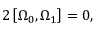<formula> <loc_0><loc_0><loc_500><loc_500>2 \left [ \Omega _ { 0 } , \Omega _ { 1 } \right ] = 0 ,</formula> 